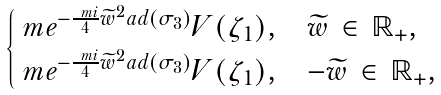Convert formula to latex. <formula><loc_0><loc_0><loc_500><loc_500>\begin{cases} \ m e ^ { - \frac { \ m i } { 4 } \widetilde { w } ^ { 2 } a d ( \sigma _ { 3 } ) } V ( \zeta _ { 1 } ) , & \text {$\widetilde{w} \, \in \, \mathbb{R}_{+}$,} \\ \ m e ^ { - \frac { \ m i } { 4 } \widetilde { w } ^ { 2 } a d ( \sigma _ { 3 } ) } V ( \zeta _ { 1 } ) , & \text {$-\widetilde{w} \, \in \, \mathbb{R}_{+}$,} \end{cases}</formula> 